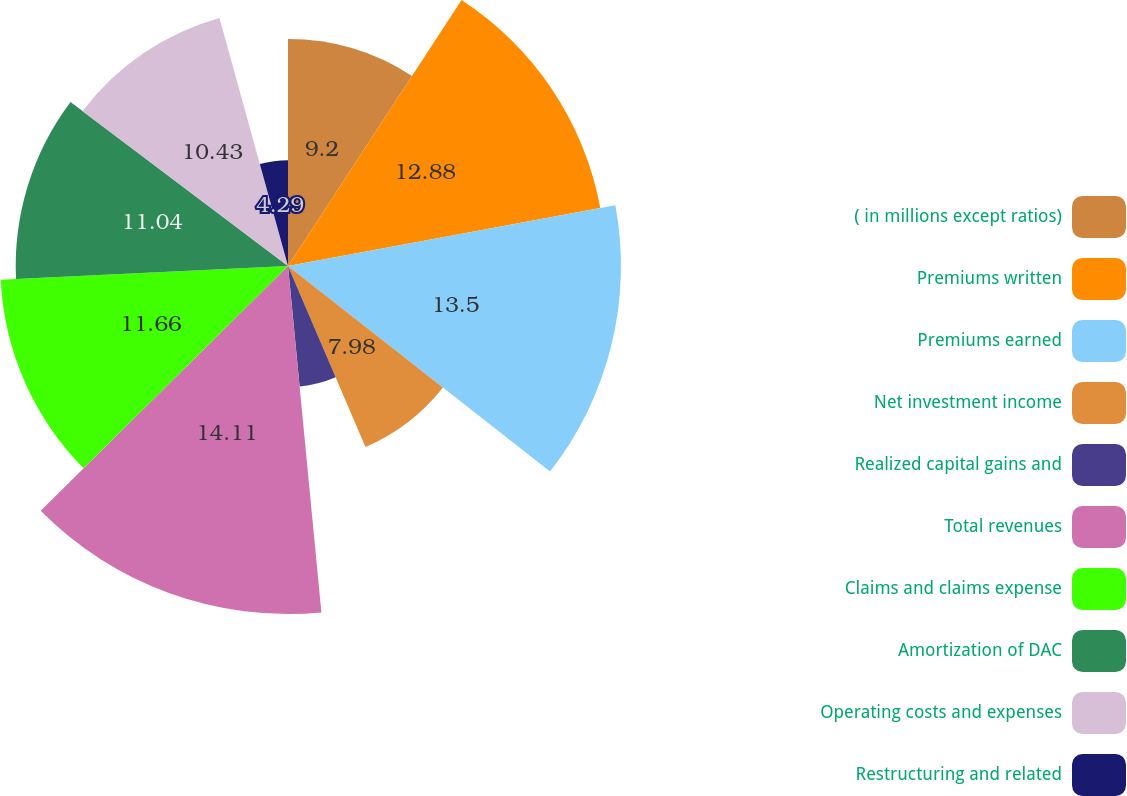Convert chart. <chart><loc_0><loc_0><loc_500><loc_500><pie_chart><fcel>( in millions except ratios)<fcel>Premiums written<fcel>Premiums earned<fcel>Net investment income<fcel>Realized capital gains and<fcel>Total revenues<fcel>Claims and claims expense<fcel>Amortization of DAC<fcel>Operating costs and expenses<fcel>Restructuring and related<nl><fcel>9.2%<fcel>12.88%<fcel>13.5%<fcel>7.98%<fcel>4.91%<fcel>14.11%<fcel>11.66%<fcel>11.04%<fcel>10.43%<fcel>4.29%<nl></chart> 